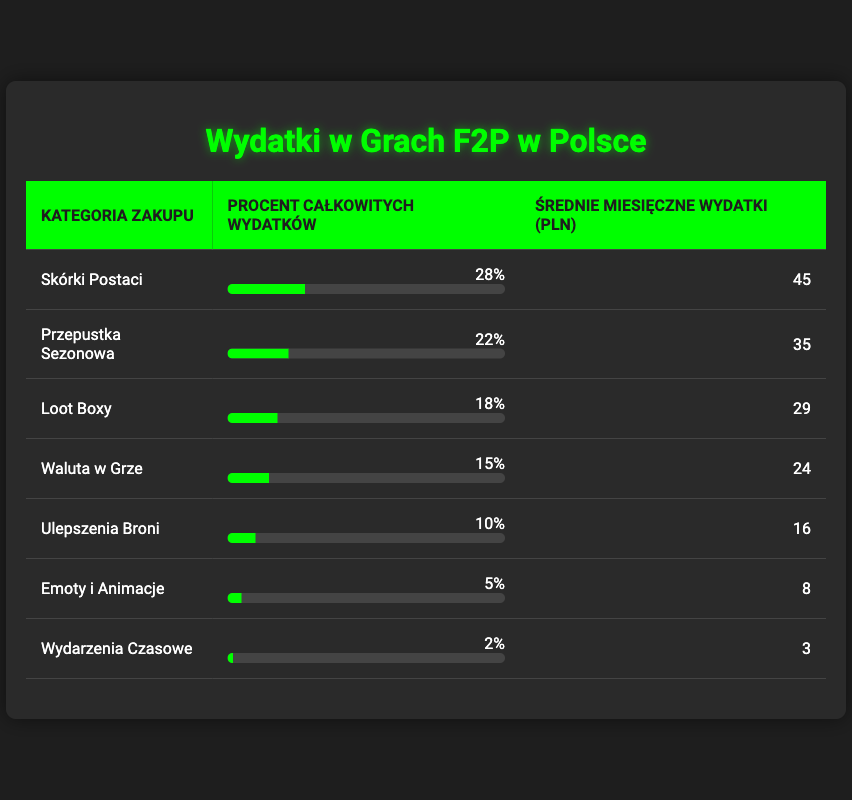What is the purchase category with the highest percentage of total spending? The table lists categories in the first column with their corresponding percentages in the second column. Looking at the percentages, "Character Skins" has the highest value at 28%.
Answer: Character Skins What is the average monthly spend on Loot Boxes? The row for "Loot Boxes" shows an average monthly spend of 29 PLN in the third column of the table.
Answer: 29 PLN Is the total percentage of spending on Emotes and Animations greater than that on Limited Time Events? From the table, "Emotes and Animations" has a spending percentage of 5%, while "Limited Time Events" has 2%. Since 5% is greater than 2%, the statement is true.
Answer: Yes What is the difference in average monthly spend between Battle Pass and In-Game Currency? Looking at the table, the average monthly spend for "Battle Pass" is 35 PLN, while for "In-Game Currency" it is 24 PLN. To find the difference, subtract: 35 - 24 = 11 PLN.
Answer: 11 PLN What percentage of total spending do Character Skins and Loot Boxes account for together? The percentage for "Character Skins" is 28% and for "Loot Boxes" it is 18%. Adding these two values together gives us 28% + 18% = 46%.
Answer: 46% What is the average monthly spend for the four highest purchase categories combined? The four highest categories are "Character Skins" (45 PLN), "Battle Pass" (35 PLN), "Loot Boxes" (29 PLN), and "In-Game Currency" (24 PLN). Adding these amounts gives us 45 + 35 + 29 + 24 = 133 PLN. To find the average for these four categories, divide by 4: 133 / 4 = 33.25 PLN.
Answer: 33.25 PLN Is there any purchase category that accounts for less than 3% of total spending? The table shows that "Limited Time Events" accounts for 2% of total spending, which is indeed less than 3%. Therefore, the statement is true.
Answer: Yes What is the total percentage of spending on Weapon Upgrades and Emotes and Animations combined? The percentage for "Weapon Upgrades" is 10% and for "Emotes and Animations" it is 5%. Adding these together gives 10% + 5% = 15%.
Answer: 15% 